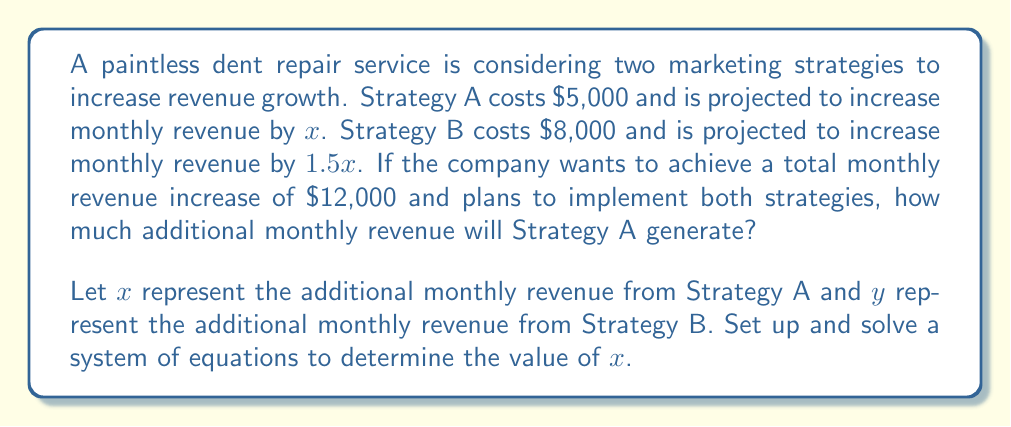Can you answer this question? Let's approach this step-by-step:

1) First, we need to set up our system of equations based on the given information:

   Equation 1: $x + y = 12000$ (total monthly revenue increase)
   Equation 2: $y = 1.5x$ (Strategy B generates 1.5 times the revenue of Strategy A)

2) Now we have a system of two equations with two unknowns:

   $$\begin{cases}
   x + y = 12000 \\
   y = 1.5x
   \end{cases}$$

3) We can solve this system by substitution. Let's substitute the second equation into the first:

   $x + 1.5x = 12000$

4) Simplify:

   $2.5x = 12000$

5) Solve for $x$:

   $x = 12000 \div 2.5 = 4800$

6) Therefore, Strategy A will generate an additional $4,800 in monthly revenue.

To verify, we can calculate $y$:
$y = 1.5x = 1.5 * 4800 = 7200$

And check that $x + y = 4800 + 7200 = 12000$, which matches our total revenue increase.
Answer: $4,800 